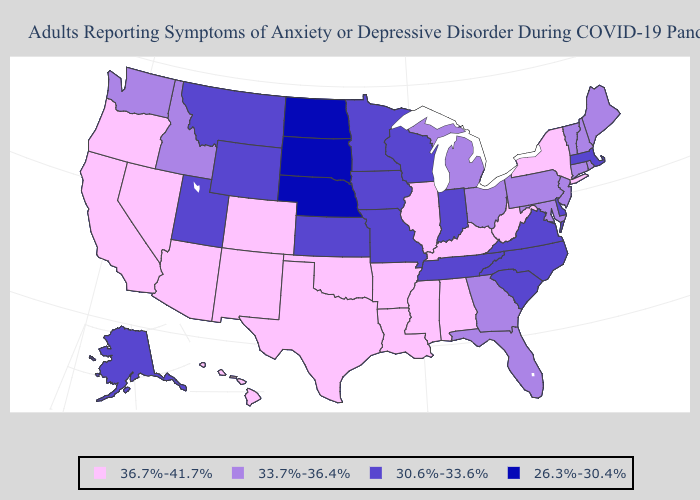What is the value of Colorado?
Answer briefly. 36.7%-41.7%. Name the states that have a value in the range 30.6%-33.6%?
Answer briefly. Alaska, Delaware, Indiana, Iowa, Kansas, Massachusetts, Minnesota, Missouri, Montana, North Carolina, South Carolina, Tennessee, Utah, Virginia, Wisconsin, Wyoming. What is the highest value in states that border Maryland?
Give a very brief answer. 36.7%-41.7%. What is the value of Louisiana?
Give a very brief answer. 36.7%-41.7%. Does Montana have a higher value than Pennsylvania?
Quick response, please. No. Among the states that border Missouri , which have the lowest value?
Quick response, please. Nebraska. Name the states that have a value in the range 26.3%-30.4%?
Concise answer only. Nebraska, North Dakota, South Dakota. Does the map have missing data?
Write a very short answer. No. Name the states that have a value in the range 36.7%-41.7%?
Write a very short answer. Alabama, Arizona, Arkansas, California, Colorado, Hawaii, Illinois, Kentucky, Louisiana, Mississippi, Nevada, New Mexico, New York, Oklahoma, Oregon, Texas, West Virginia. Does Pennsylvania have the same value as Mississippi?
Give a very brief answer. No. Does the map have missing data?
Be succinct. No. What is the value of Iowa?
Be succinct. 30.6%-33.6%. What is the value of Texas?
Concise answer only. 36.7%-41.7%. What is the value of South Carolina?
Be succinct. 30.6%-33.6%. What is the value of Utah?
Be succinct. 30.6%-33.6%. 